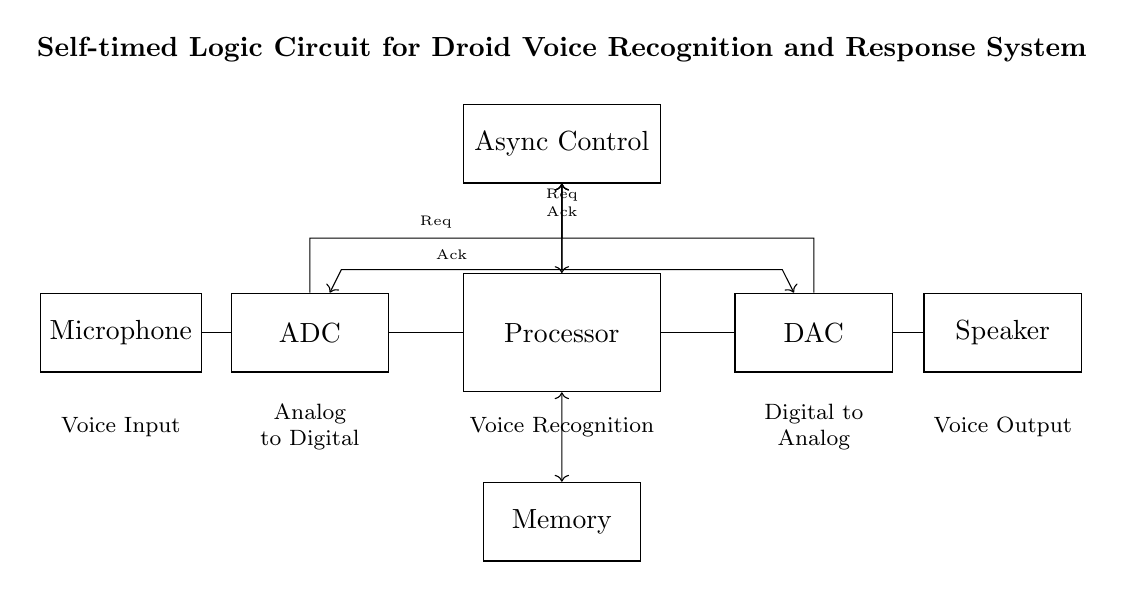What is the function of the microphone? The microphone is labeled as the "Voice Input" component, which indicates its role in capturing sound for the system.
Answer: Voice Input What type of control does the circuit utilize? The circuit utilizes "Asynchronous Control," as indicated in the diagram, allowing components to operate independently without a global clock signal.
Answer: Asynchronous Control How many main components are shown in the circuit? The diagram shows five main components: Microphone, ADC, Processor, DAC, and Speaker, which are clearly labeled and arranged sequentially.
Answer: Five What signals are sent between the ADC and the control unit? The ADC sends a request signal (Req) and receives an acknowledgment signal (Ack) from the control unit, as shown in the diagram with directional arrows and labels.
Answer: Request and Acknowledge What is the purpose of the memory block in the circuit? The memory block serves to store data temporarily during processing, facilitating the operation of the Processor as indicated by the bidirectional arrows connecting these components.
Answer: Data Storage Which component converts analog signals to digital? The ADC is responsible for converting the analog voice input from the microphone into a digital format, which is indicated in its label, "Analog to Digital."
Answer: ADC Which two components are directly connected to the processor? The Processor is directly connected to the Memory in one direction and to the ADC in another, as shown by the lines connecting these components in the diagram.
Answer: ADC and Memory 